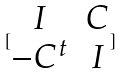Convert formula to latex. <formula><loc_0><loc_0><loc_500><loc_500>[ \begin{matrix} I & C \\ - C ^ { t } & I \end{matrix} ]</formula> 